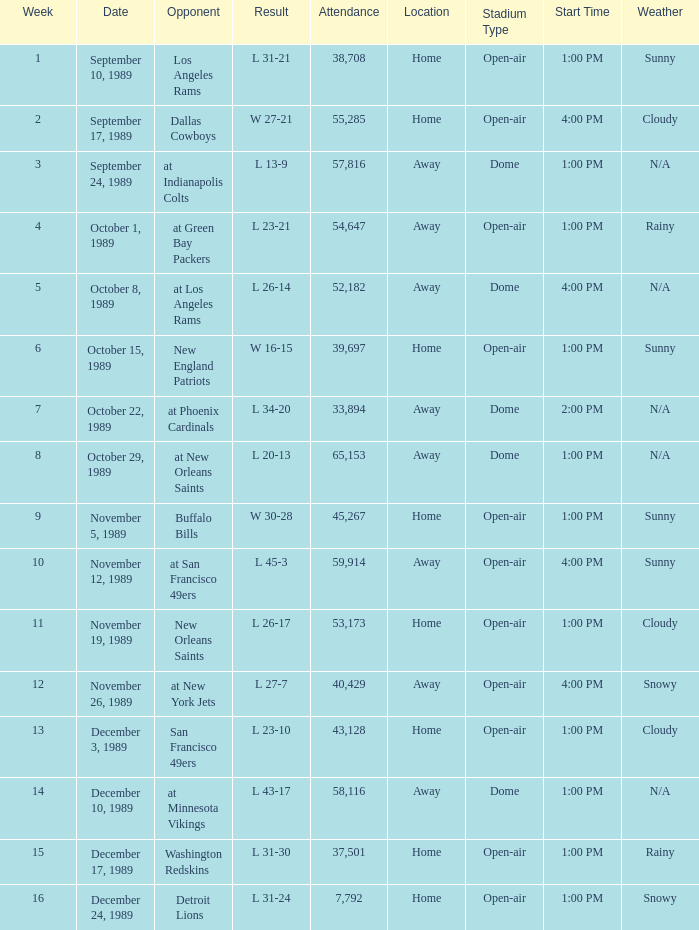On September 10, 1989 how many people attended the game? 38708.0. 